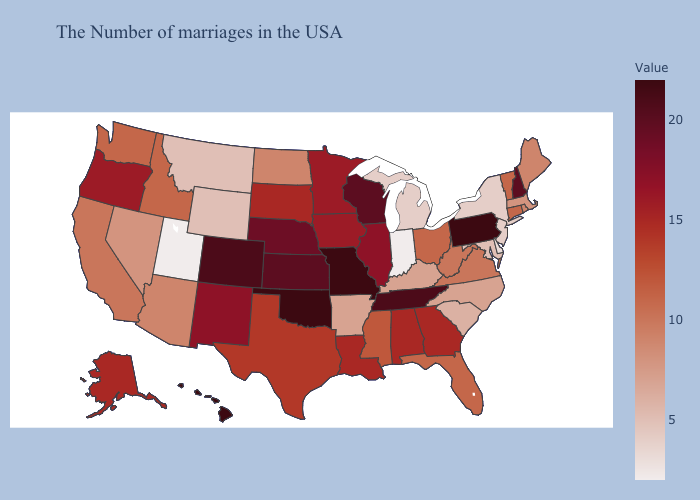Which states have the lowest value in the South?
Concise answer only. Delaware. Does Tennessee have a lower value than Wyoming?
Quick response, please. No. Among the states that border Pennsylvania , does New Jersey have the highest value?
Quick response, please. No. Does South Carolina have the lowest value in the USA?
Answer briefly. No. Among the states that border Rhode Island , does Massachusetts have the lowest value?
Keep it brief. Yes. Does the map have missing data?
Be succinct. No. 